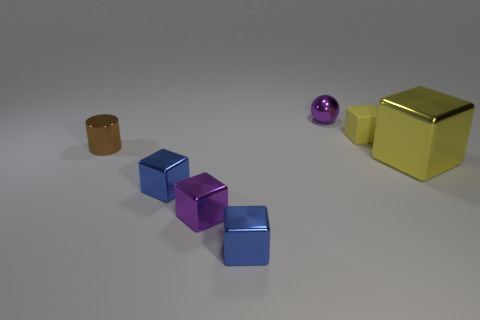The small cube behind the big metallic cube is what color?
Your response must be concise. Yellow. There is a small blue cube that is left of the small blue metallic object that is in front of the blue cube left of the purple cube; what is its material?
Your response must be concise. Metal. Is there another large metallic object of the same shape as the big thing?
Give a very brief answer. No. There is a yellow object that is the same size as the brown cylinder; what is its shape?
Your response must be concise. Cube. What number of metallic things are behind the large yellow block and on the right side of the small cylinder?
Make the answer very short. 1. Are there fewer blocks right of the purple metallic ball than yellow matte spheres?
Provide a succinct answer. No. Are there any other metal blocks of the same size as the purple metal block?
Provide a short and direct response. Yes. The big block that is made of the same material as the small sphere is what color?
Keep it short and to the point. Yellow. There is a small purple thing in front of the yellow shiny block; what number of metal objects are on the left side of it?
Offer a very short reply. 2. What is the object that is in front of the small brown metallic cylinder and left of the purple block made of?
Your answer should be compact. Metal. 